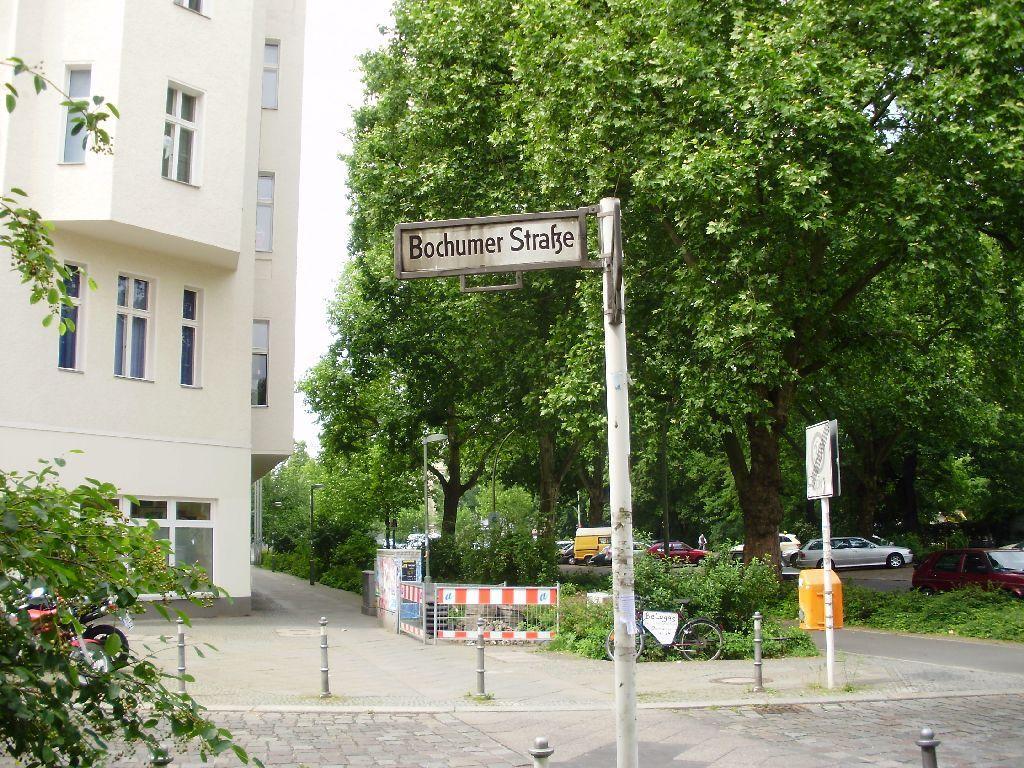Describe this image in one or two sentences. In this image we can see few trees, plants, few vehicles on the road, a pole with board and a pole with board and a box, there is a building on the left side, there are few rods, and the sky in the background. 